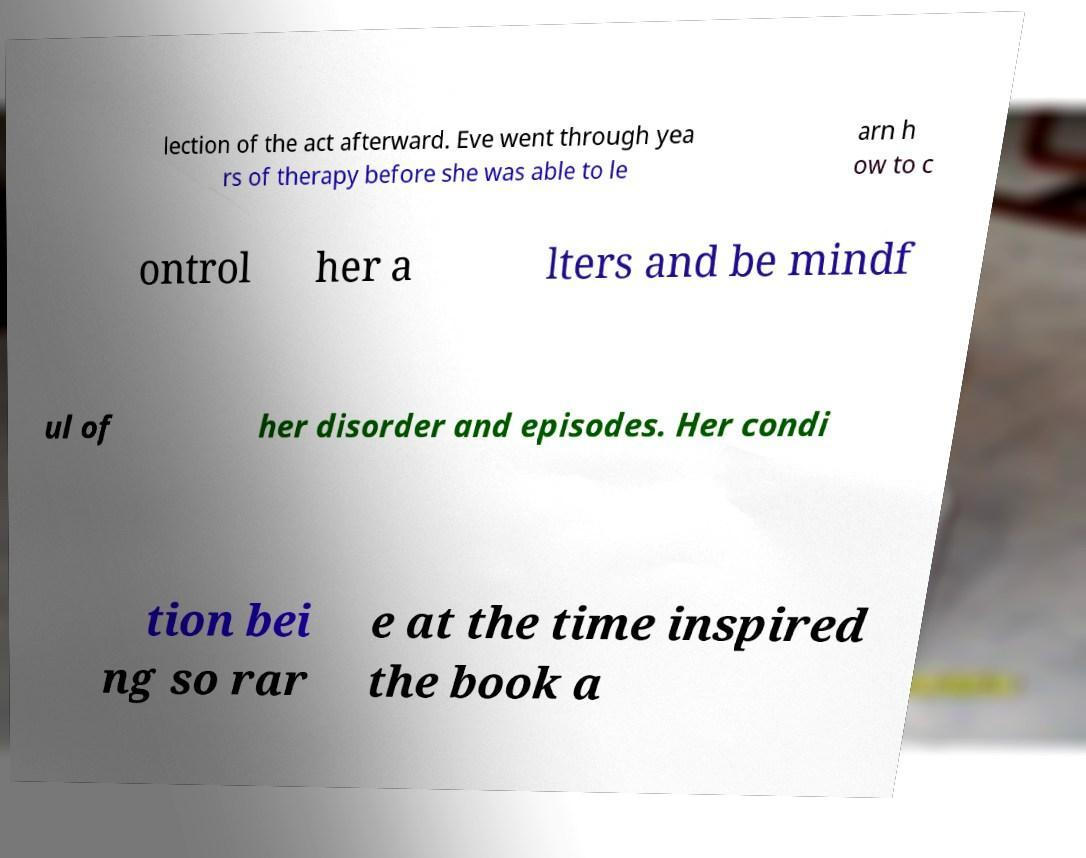There's text embedded in this image that I need extracted. Can you transcribe it verbatim? lection of the act afterward. Eve went through yea rs of therapy before she was able to le arn h ow to c ontrol her a lters and be mindf ul of her disorder and episodes. Her condi tion bei ng so rar e at the time inspired the book a 